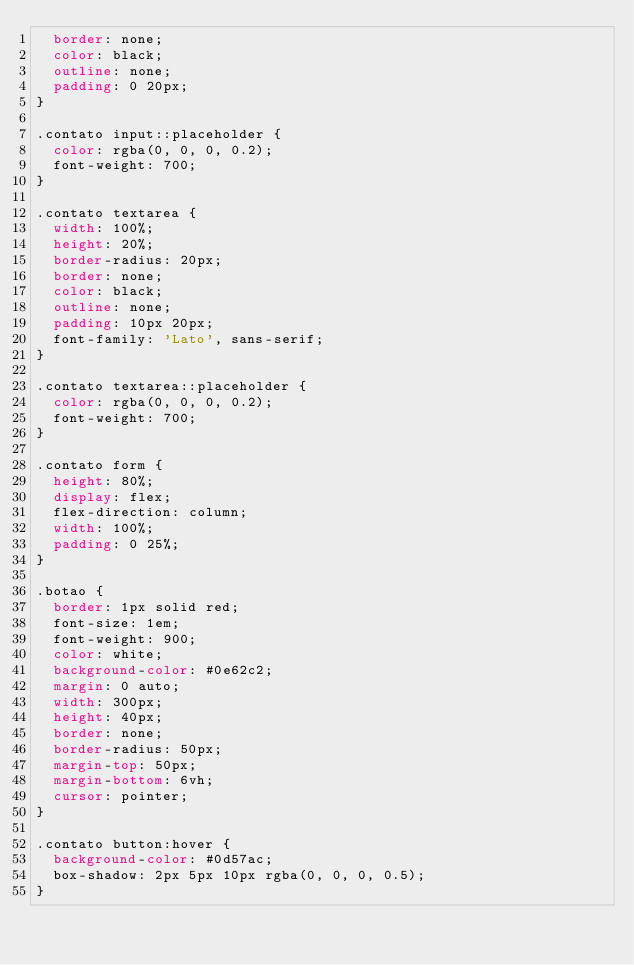Convert code to text. <code><loc_0><loc_0><loc_500><loc_500><_CSS_>  border: none;
  color: black;
  outline: none;
  padding: 0 20px;
}

.contato input::placeholder {
  color: rgba(0, 0, 0, 0.2);
  font-weight: 700;
}

.contato textarea {
  width: 100%;
  height: 20%;
  border-radius: 20px;
  border: none;
  color: black;
  outline: none;
  padding: 10px 20px;
  font-family: 'Lato', sans-serif;
}

.contato textarea::placeholder {
  color: rgba(0, 0, 0, 0.2);
  font-weight: 700;
}

.contato form {
  height: 80%;
  display: flex;
  flex-direction: column;
  width: 100%;
  padding: 0 25%;
}

.botao {
  border: 1px solid red;
  font-size: 1em;
  font-weight: 900;
  color: white;
  background-color: #0e62c2;
  margin: 0 auto;
  width: 300px;
  height: 40px;
  border: none;
  border-radius: 50px;
  margin-top: 50px;
  margin-bottom: 6vh;
  cursor: pointer;
}

.contato button:hover {
  background-color: #0d57ac;
  box-shadow: 2px 5px 10px rgba(0, 0, 0, 0.5);
}
</code> 